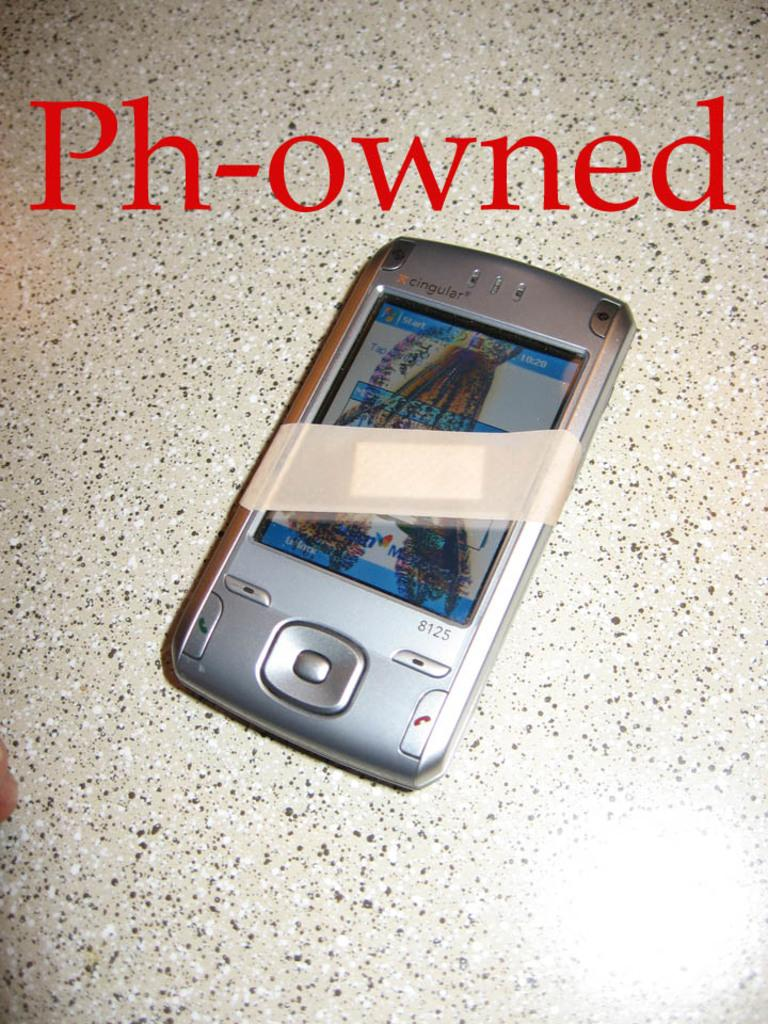<image>
Offer a succinct explanation of the picture presented. a phone has the word owned above it 